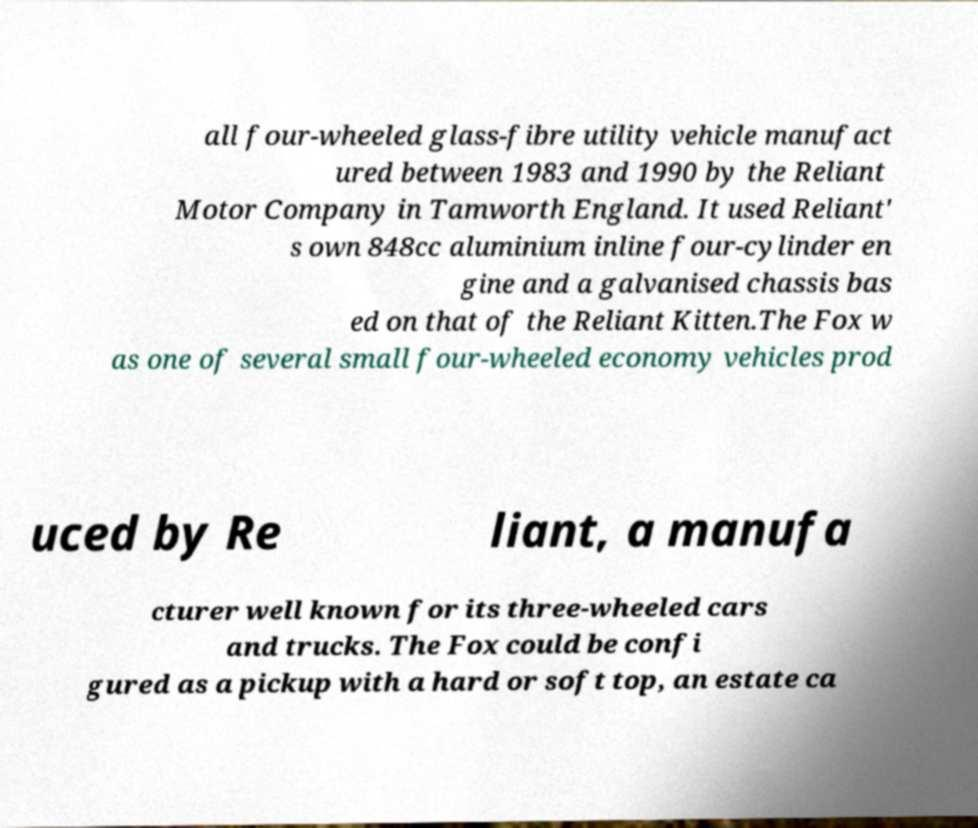Could you assist in decoding the text presented in this image and type it out clearly? all four-wheeled glass-fibre utility vehicle manufact ured between 1983 and 1990 by the Reliant Motor Company in Tamworth England. It used Reliant' s own 848cc aluminium inline four-cylinder en gine and a galvanised chassis bas ed on that of the Reliant Kitten.The Fox w as one of several small four-wheeled economy vehicles prod uced by Re liant, a manufa cturer well known for its three-wheeled cars and trucks. The Fox could be confi gured as a pickup with a hard or soft top, an estate ca 